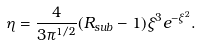Convert formula to latex. <formula><loc_0><loc_0><loc_500><loc_500>\eta = \frac { 4 } { 3 \pi ^ { 1 / 2 } } ( R _ { s u b } - 1 ) \xi ^ { 3 } e ^ { - \xi ^ { 2 } } .</formula> 